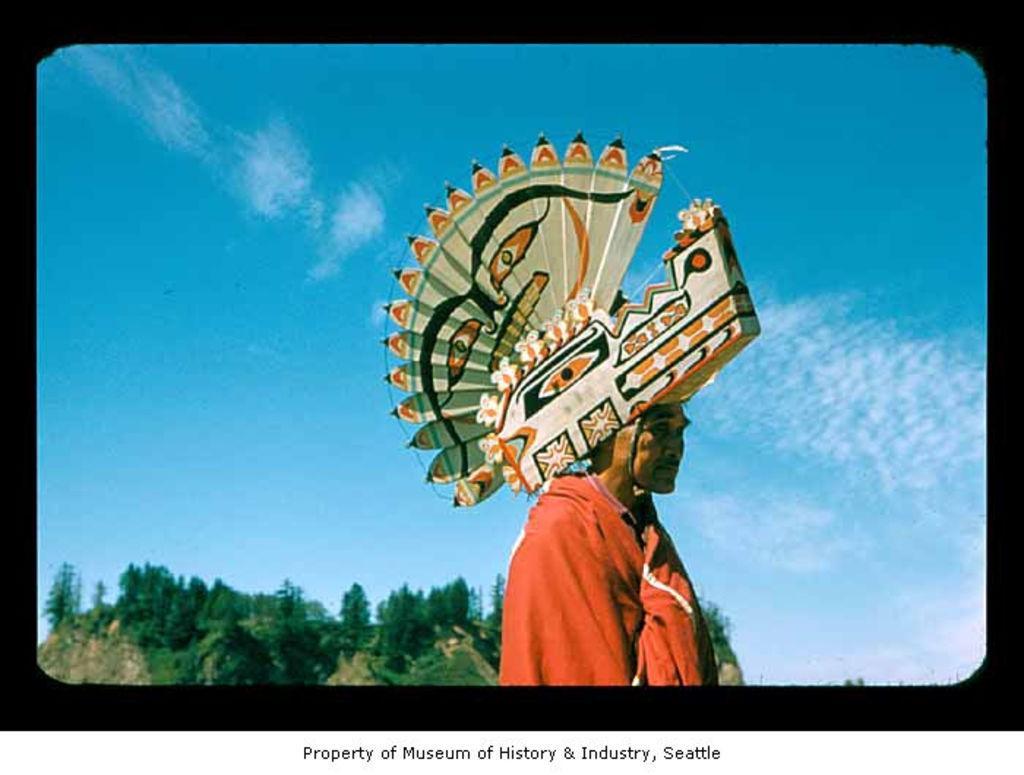Please provide a concise description of this image. It is an edited image,there is a man and he is carrying a property on his head,he is wearing a red costume and behind the man there are lot of trees and in the background there is a sky. 